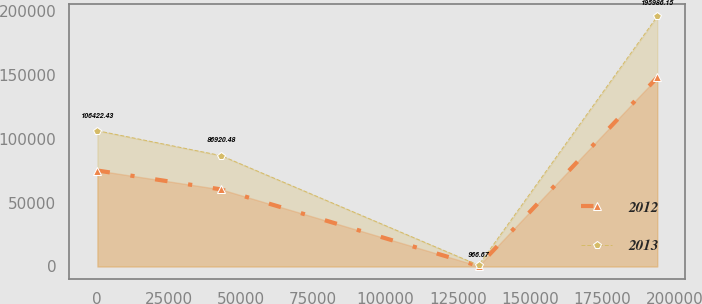Convert chart. <chart><loc_0><loc_0><loc_500><loc_500><line_chart><ecel><fcel>2012<fcel>2013<nl><fcel>282<fcel>75225.8<fcel>106422<nl><fcel>43066.4<fcel>60451.3<fcel>86920.5<nl><fcel>132230<fcel>421.7<fcel>966.67<nl><fcel>194077<fcel>148166<fcel>195986<nl></chart> 